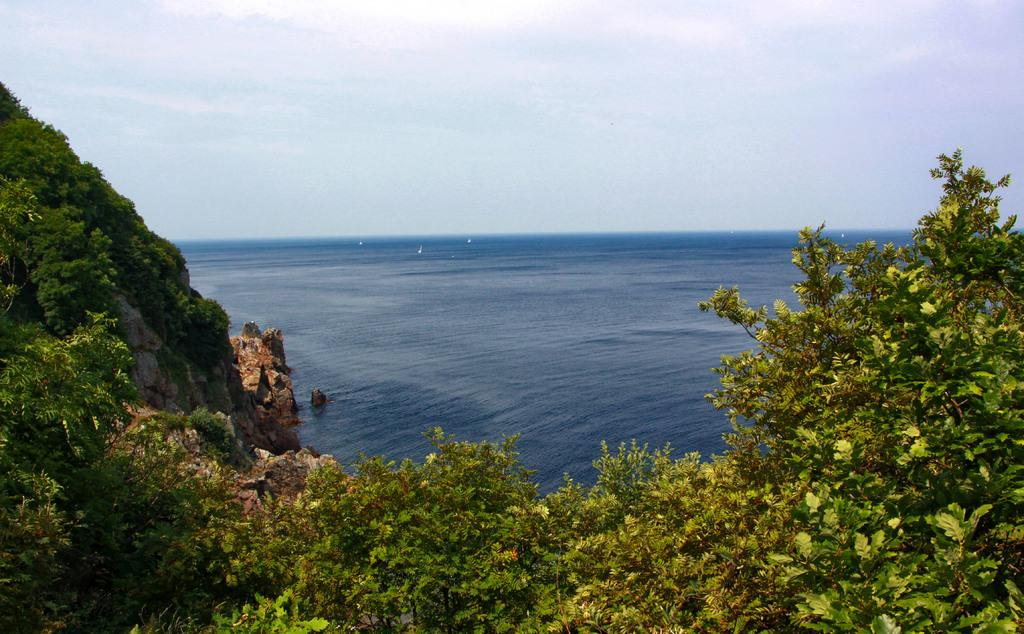What type of natural environment is depicted in the image? The image features many trees, suggesting a forest or wooded area. What can be seen in the background of the image? There is water and the sky visible in the background of the image. Can you describe the sky in the image? The sky is visible in the background of the image, but no specific details about its appearance are provided. What type of linen is draped over the trees in the image? There is no linen present in the image; it features trees, water, and the sky. How many dolls are sitting on the branches of the trees in the image? There are no dolls present in the image; it features trees, water, and the sky. 